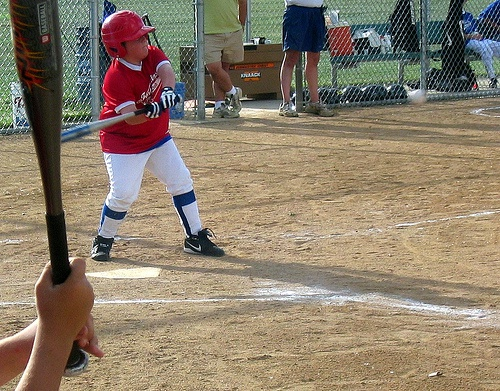Describe the objects in this image and their specific colors. I can see people in gray, maroon, darkgray, and brown tones, baseball bat in gray, black, and maroon tones, people in gray, maroon, and brown tones, people in gray, olive, and maroon tones, and bench in gray, black, purple, and darkgray tones in this image. 